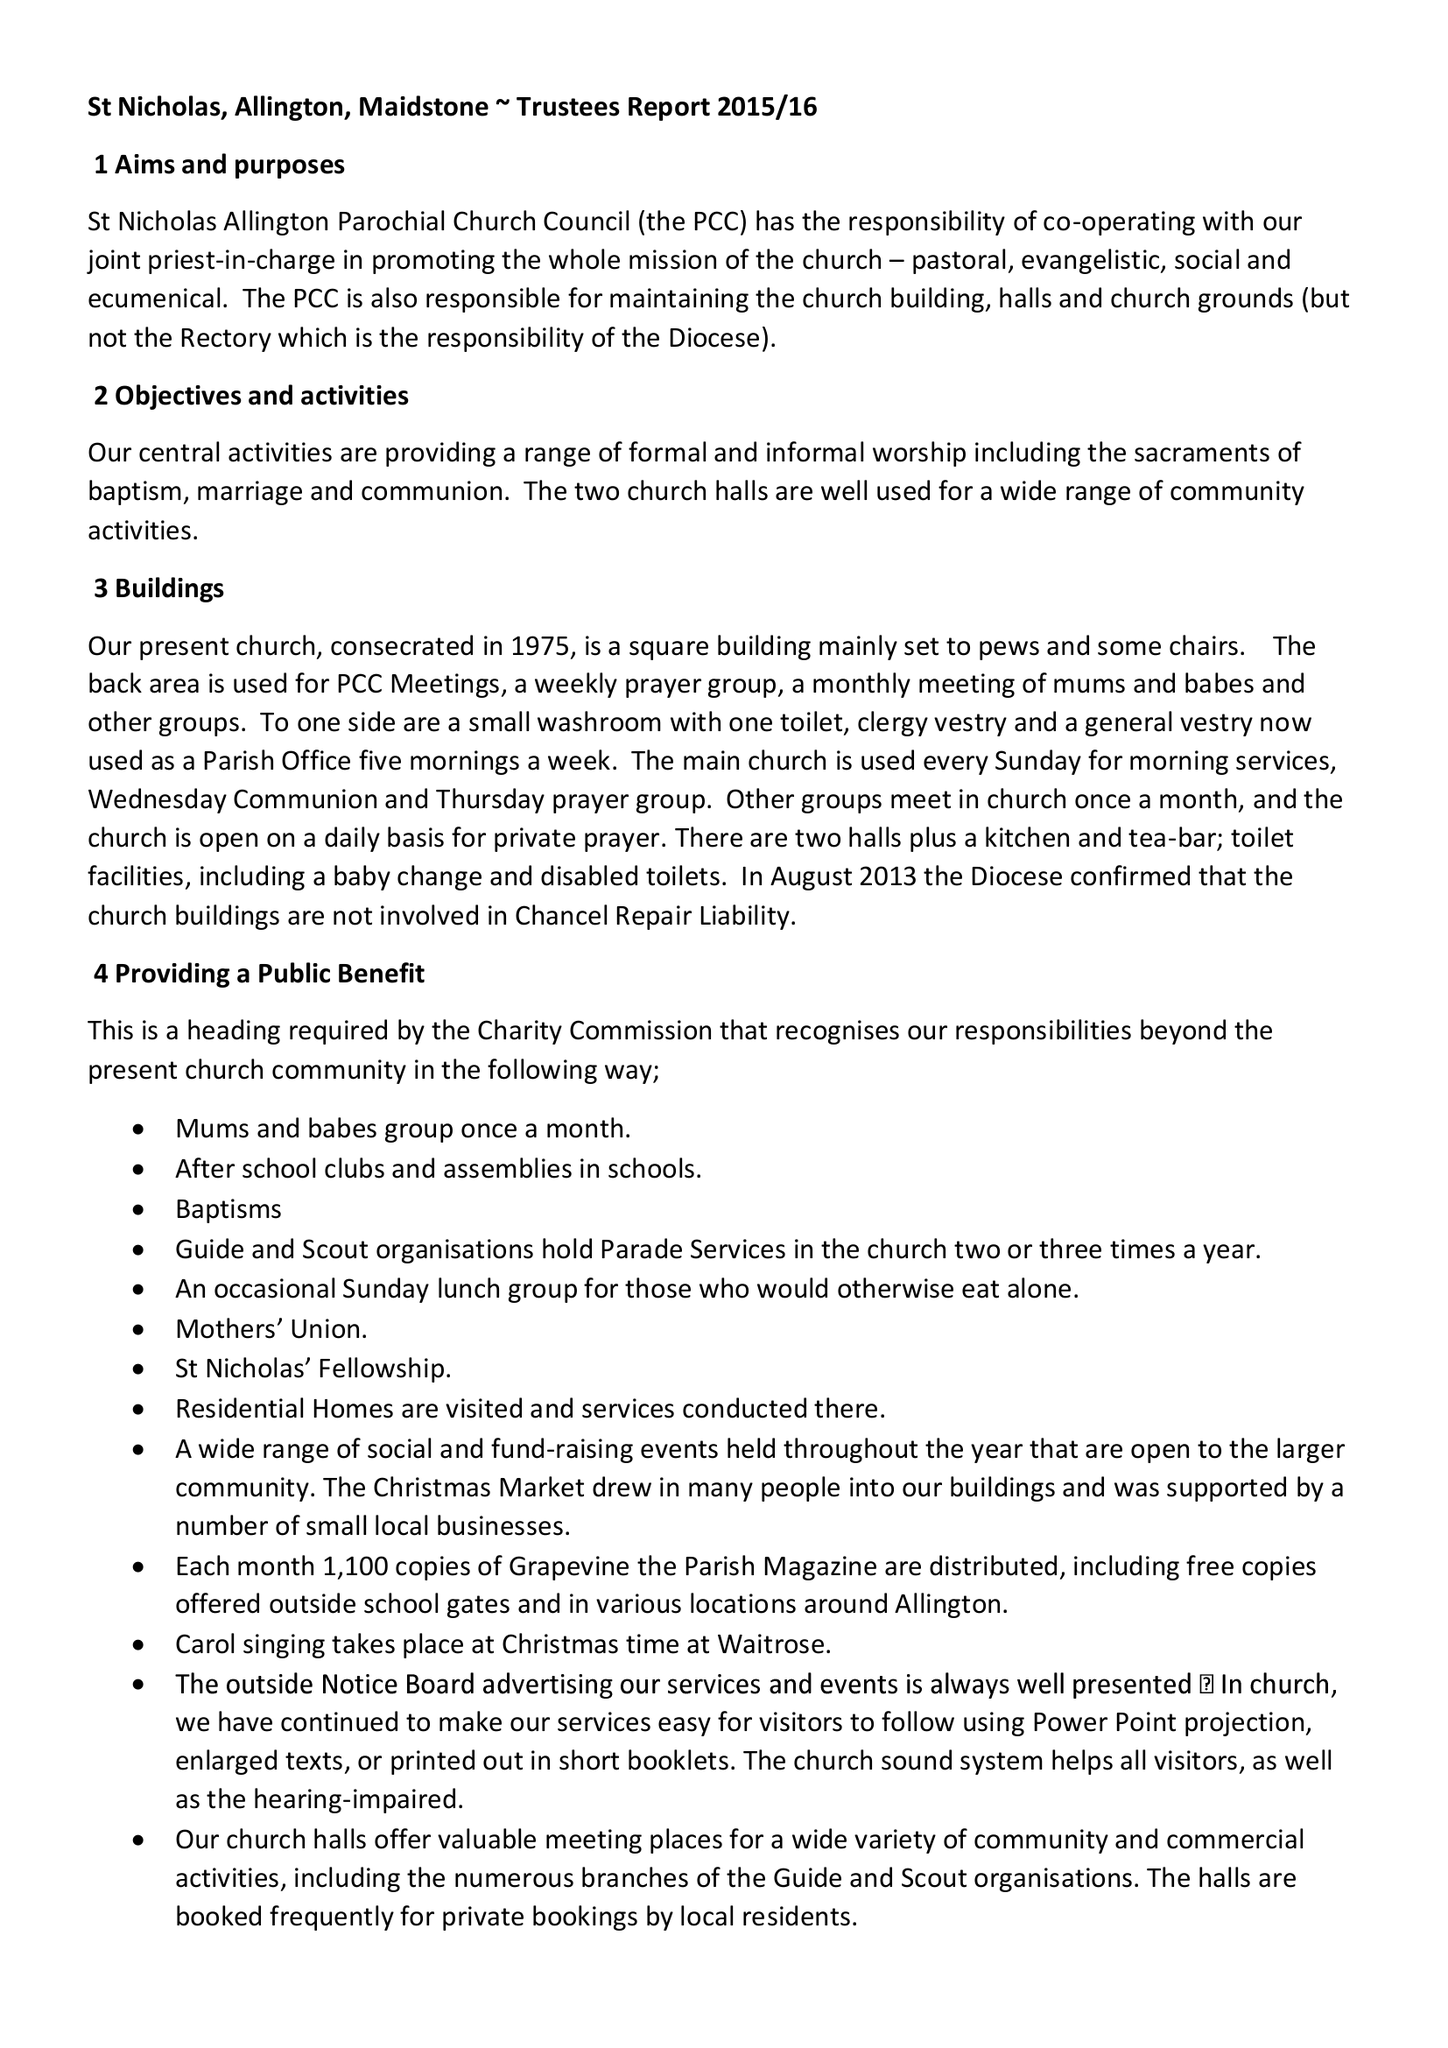What is the value for the spending_annually_in_british_pounds?
Answer the question using a single word or phrase. 113443.00 